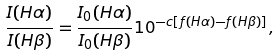<formula> <loc_0><loc_0><loc_500><loc_500>\frac { I ( H \alpha ) } { I ( H \beta ) } = \frac { I _ { 0 } ( H \alpha ) } { I _ { 0 } ( H \beta ) } 1 0 ^ { - c [ f ( H \alpha ) - f ( H \beta ) ] } ,</formula> 